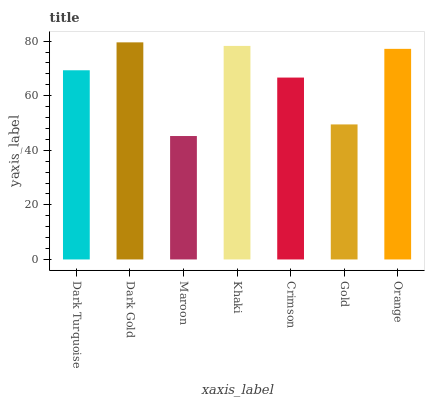Is Maroon the minimum?
Answer yes or no. Yes. Is Dark Gold the maximum?
Answer yes or no. Yes. Is Dark Gold the minimum?
Answer yes or no. No. Is Maroon the maximum?
Answer yes or no. No. Is Dark Gold greater than Maroon?
Answer yes or no. Yes. Is Maroon less than Dark Gold?
Answer yes or no. Yes. Is Maroon greater than Dark Gold?
Answer yes or no. No. Is Dark Gold less than Maroon?
Answer yes or no. No. Is Dark Turquoise the high median?
Answer yes or no. Yes. Is Dark Turquoise the low median?
Answer yes or no. Yes. Is Maroon the high median?
Answer yes or no. No. Is Gold the low median?
Answer yes or no. No. 